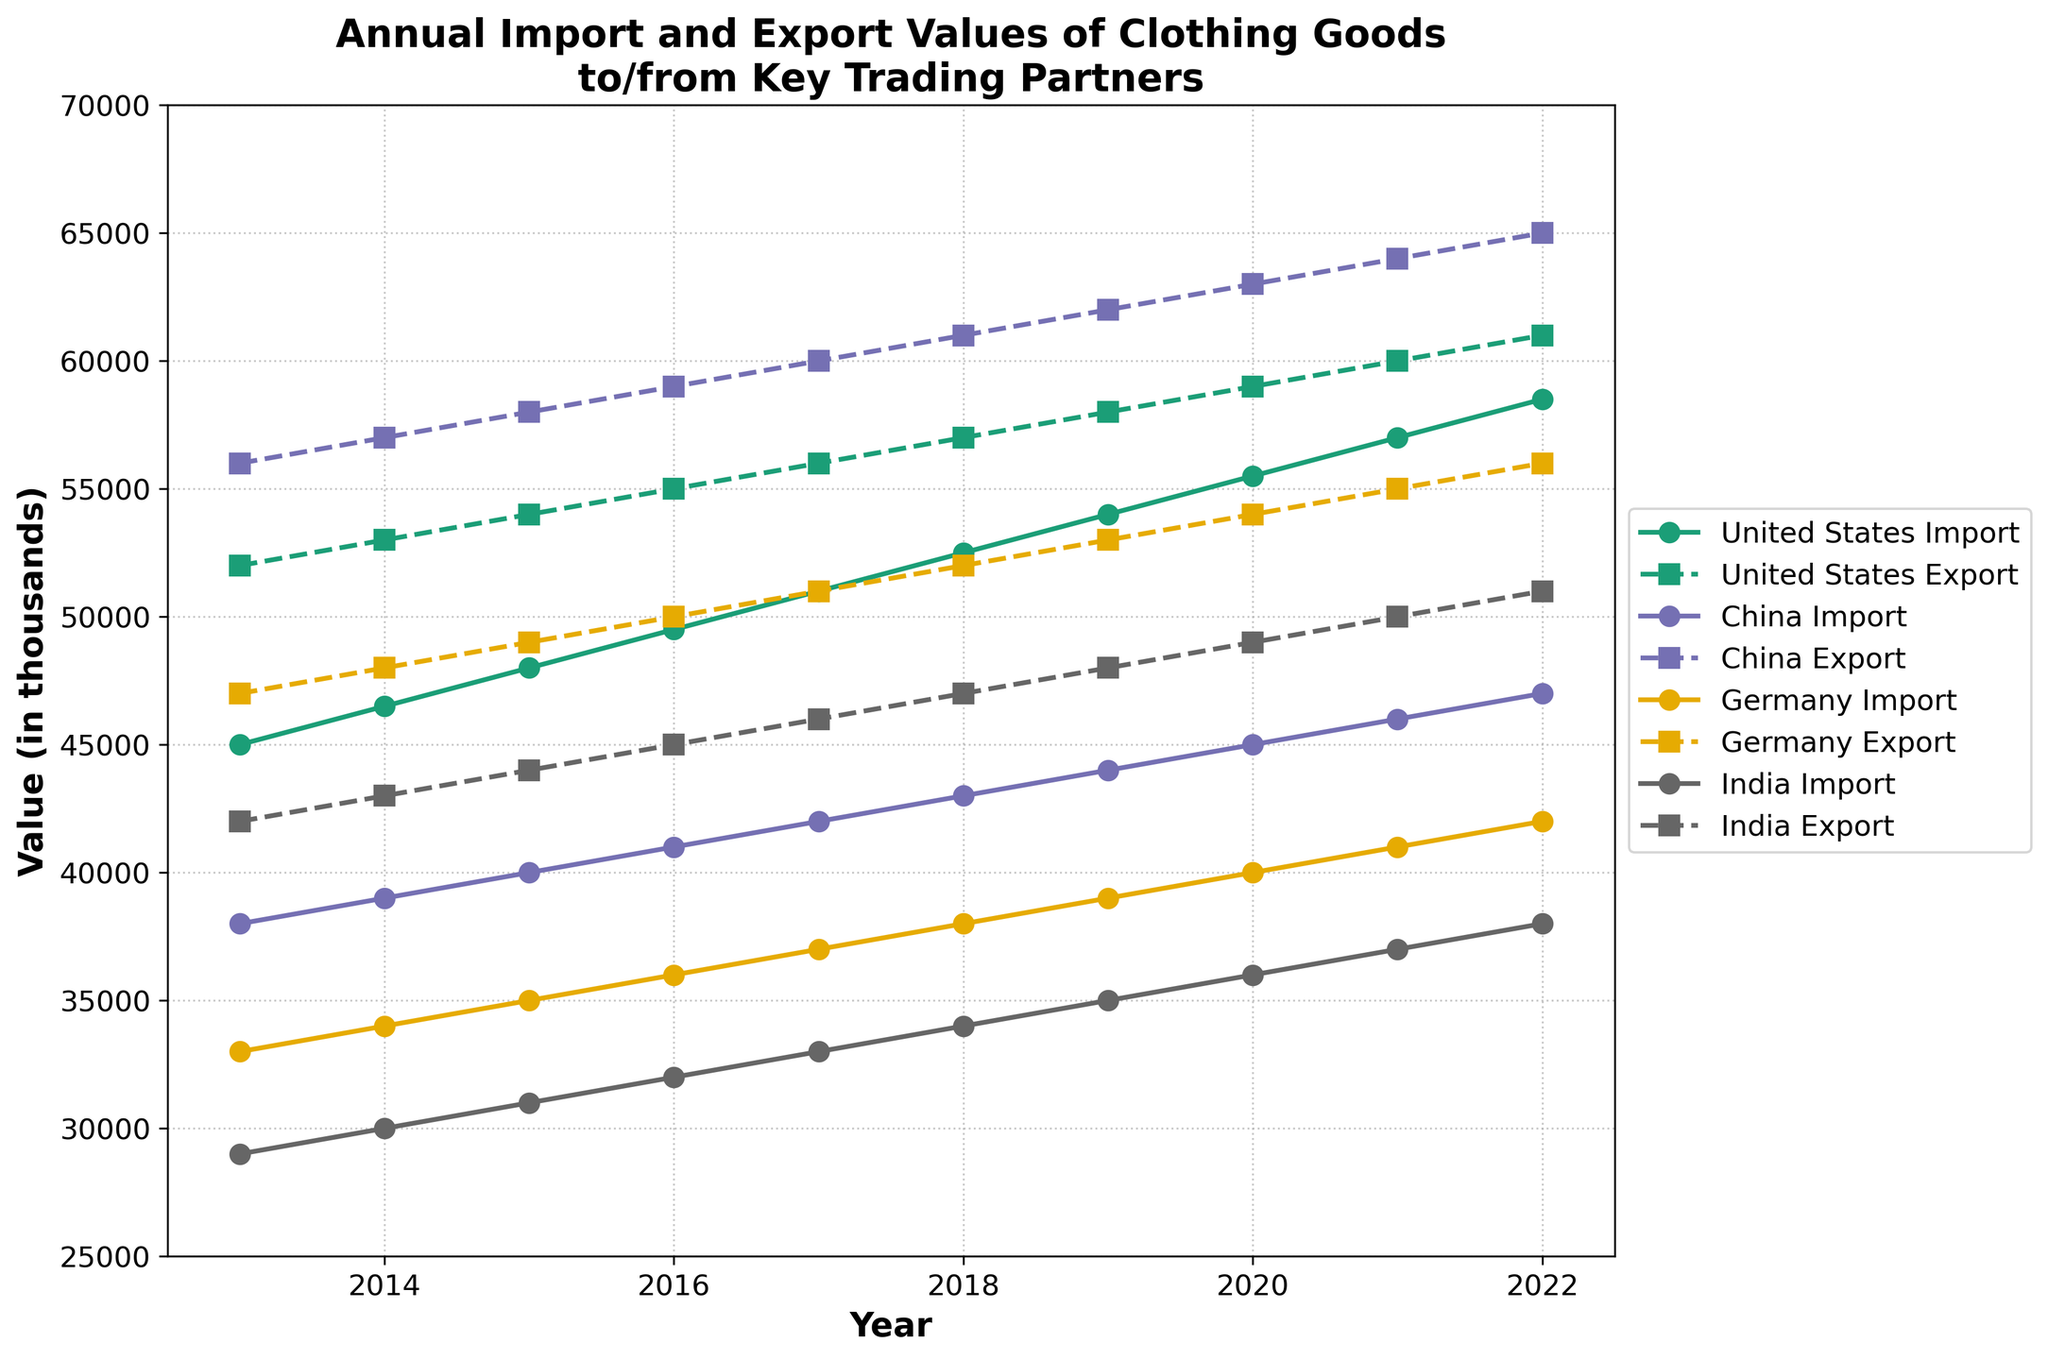What is the title of the figure? The title is usually displayed prominently at the top of the plot. The given code specifies the title as "Annual Import and Export Values of Clothing Goods to/from Key Trading Partners"
Answer: Annual Import and Export Values of Clothing Goods to/from Key Trading Partners Which country had the highest export value in 2017? The export values for each country in 2017 can be found along the y-axis for that year. According to the data, China had the highest export value in 2017 with 60,000.
Answer: China What is the import value for India in 2015? By looking at India's data line in 2015, we check the value corresponding to the y-axis. The value listed is 31,000.
Answer: 31,000 How did Germany's import values change from 2013 to 2022? To observe the change, compare the import values in 2013 (33,000) and 2022 (42,000). The change is 42,000 - 33,000 = 9,000.
Answer: Increased by 9,000 What is the average export value for the United States over the last decade? Sum the export values for all years for the United States and divide by the number of years. So the sum is: 52000 + 53000 + 54000 + 55000 + 56000 + 57000 + 58000 + 59000 + 60000 + 61000 = 565000. Then, 565000 / 10 = 56500.
Answer: 56,500 Between 2015 and 2020, which country showed the greatest increase in export values? Calculate the increase for each country between these years. 
- United States: 59,000 - 54,000 = 5,000
- China: 63,000 - 58,000 = 5,000
- Germany: 54,000 - 49,000 = 5,000
- India: 49,000 - 44,000 = 5,000
All countries had an equal increase of 5,000.
Answer: All countries Which country's import values crossed 50,000 first and in which year? By examining each country’s import line, China crossed 50,000 in 2021.
Answer: China, 2021 Are the import values for the United States and India ever the same? If so, when? Compare the import values for both countries over all years. They are never the same at any given year.
Answer: No Which country had the most consistent export growth from 2013 to 2022? By observing the export lines, China consistently increases every year from 56,000 in 2013 to 65,000 in 2022 without any dips or plateau.
Answer: China 